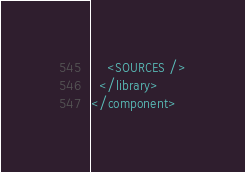Convert code to text. <code><loc_0><loc_0><loc_500><loc_500><_XML_>    <SOURCES />
  </library>
</component></code> 